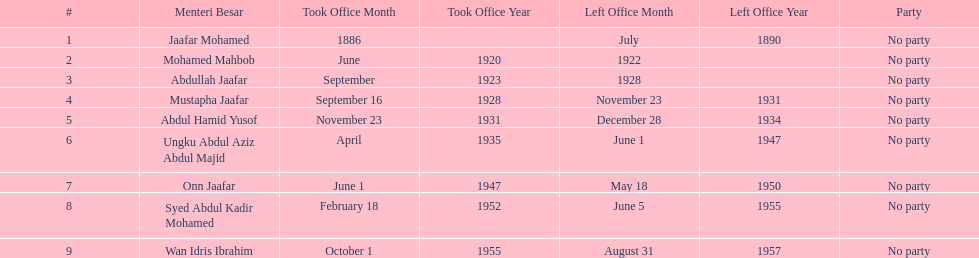How many years was jaafar mohamed in office? 4. 